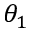Convert formula to latex. <formula><loc_0><loc_0><loc_500><loc_500>\theta _ { 1 }</formula> 